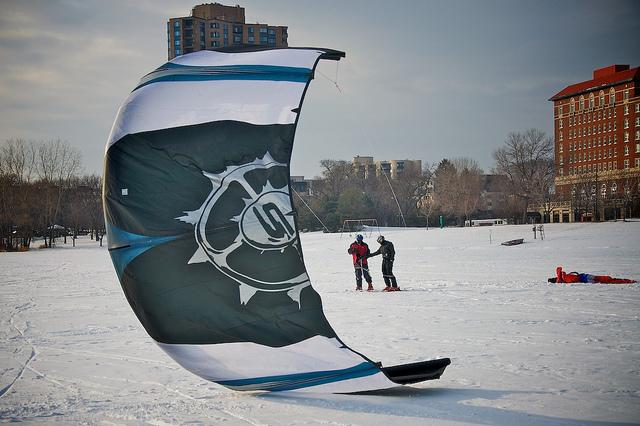What is this object?
Concise answer only. Sail. Are there many leaves on the trees?
Answer briefly. No. What kind of season is it?
Write a very short answer. Winter. 